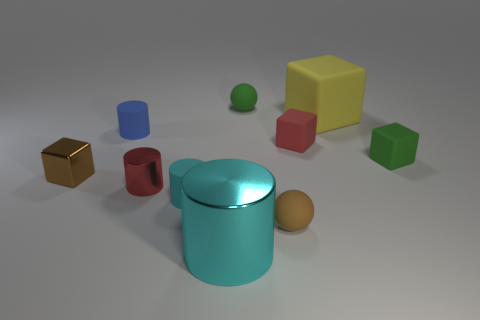There is a small cyan object that is the same shape as the blue matte thing; what material is it?
Provide a succinct answer. Rubber. What color is the block that is both to the left of the large yellow matte cube and to the right of the brown metallic thing?
Your response must be concise. Red. Is the number of blue things less than the number of large cyan balls?
Your response must be concise. No. Is the color of the metallic cube the same as the tiny ball that is in front of the large matte cube?
Provide a succinct answer. Yes. Are there an equal number of small matte cylinders to the right of the cyan rubber cylinder and red matte cubes on the right side of the tiny blue cylinder?
Your answer should be compact. No. How many brown objects are the same shape as the small red metallic thing?
Offer a very short reply. 0. Are any big red cylinders visible?
Your answer should be compact. No. Does the small green cube have the same material as the sphere that is to the left of the tiny brown matte sphere?
Your answer should be compact. Yes. There is a cyan object that is the same size as the blue rubber cylinder; what is its material?
Your answer should be very brief. Rubber. Is there a large green cylinder that has the same material as the tiny blue cylinder?
Provide a short and direct response. No. 